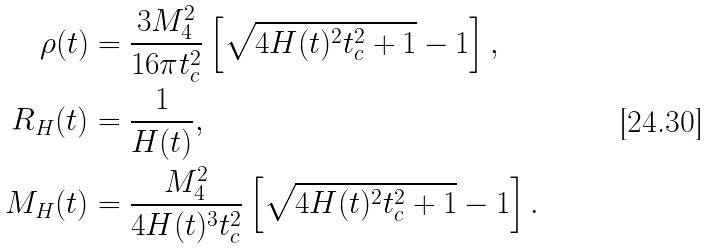Convert formula to latex. <formula><loc_0><loc_0><loc_500><loc_500>\rho ( t ) & = \frac { 3 M _ { 4 } ^ { 2 } } { 1 6 \pi t _ { c } ^ { 2 } } \left [ \sqrt { 4 H ( t ) ^ { 2 } t _ { c } ^ { 2 } + 1 } - 1 \right ] , \\ R _ { H } ( t ) & = \frac { 1 } { H ( t ) } , \\ M _ { H } ( t ) & = \frac { M _ { 4 } ^ { 2 } } { 4 H ( t ) ^ { 3 } t _ { c } ^ { 2 } } \left [ \sqrt { 4 H ( t ) ^ { 2 } t _ { c } ^ { 2 } + 1 } - 1 \right ] .</formula> 